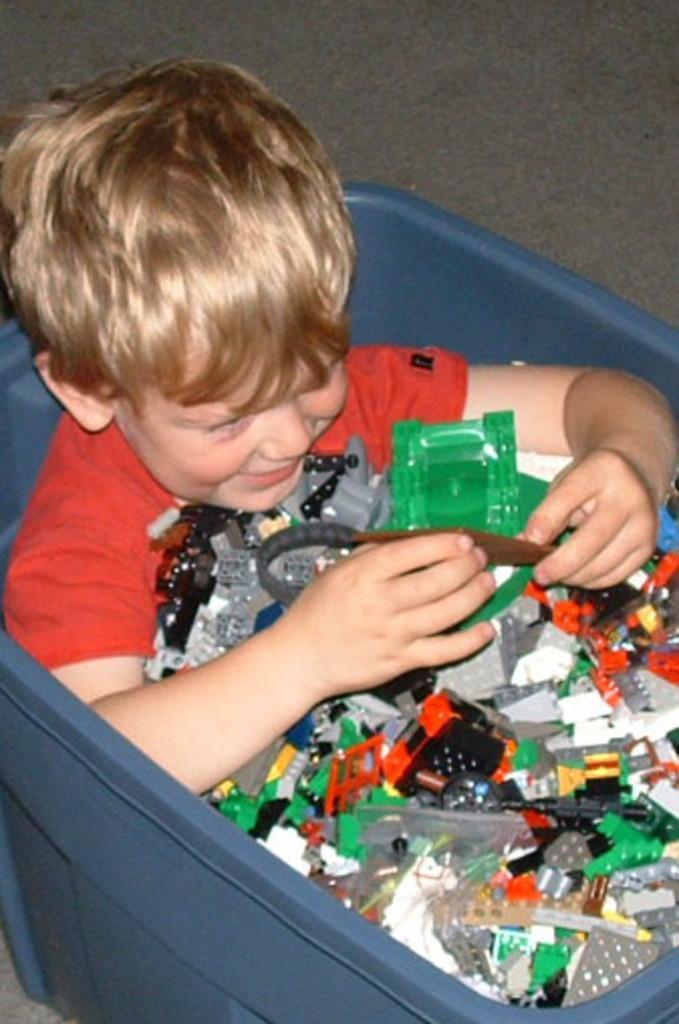Please provide a concise description of this image. In this image I can see a person is sitting inside the blue box. He is wearing red color top and few multicolor objects inside. 